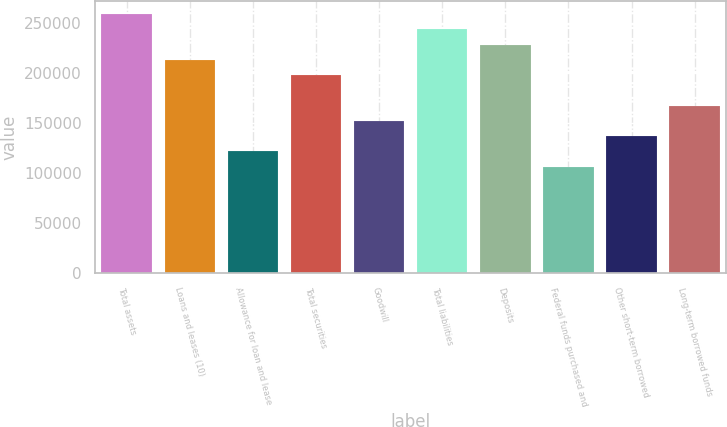Convert chart to OTSL. <chart><loc_0><loc_0><loc_500><loc_500><bar_chart><fcel>Total assets<fcel>Loans and leases (10)<fcel>Allowance for loan and lease<fcel>Total securities<fcel>Goodwill<fcel>Total liabilities<fcel>Deposits<fcel>Federal funds purchased and<fcel>Other short-term borrowed<fcel>Long-term borrowed funds<nl><fcel>258971<fcel>213270<fcel>121869<fcel>198037<fcel>152336<fcel>243737<fcel>228504<fcel>106635<fcel>137102<fcel>167570<nl></chart> 